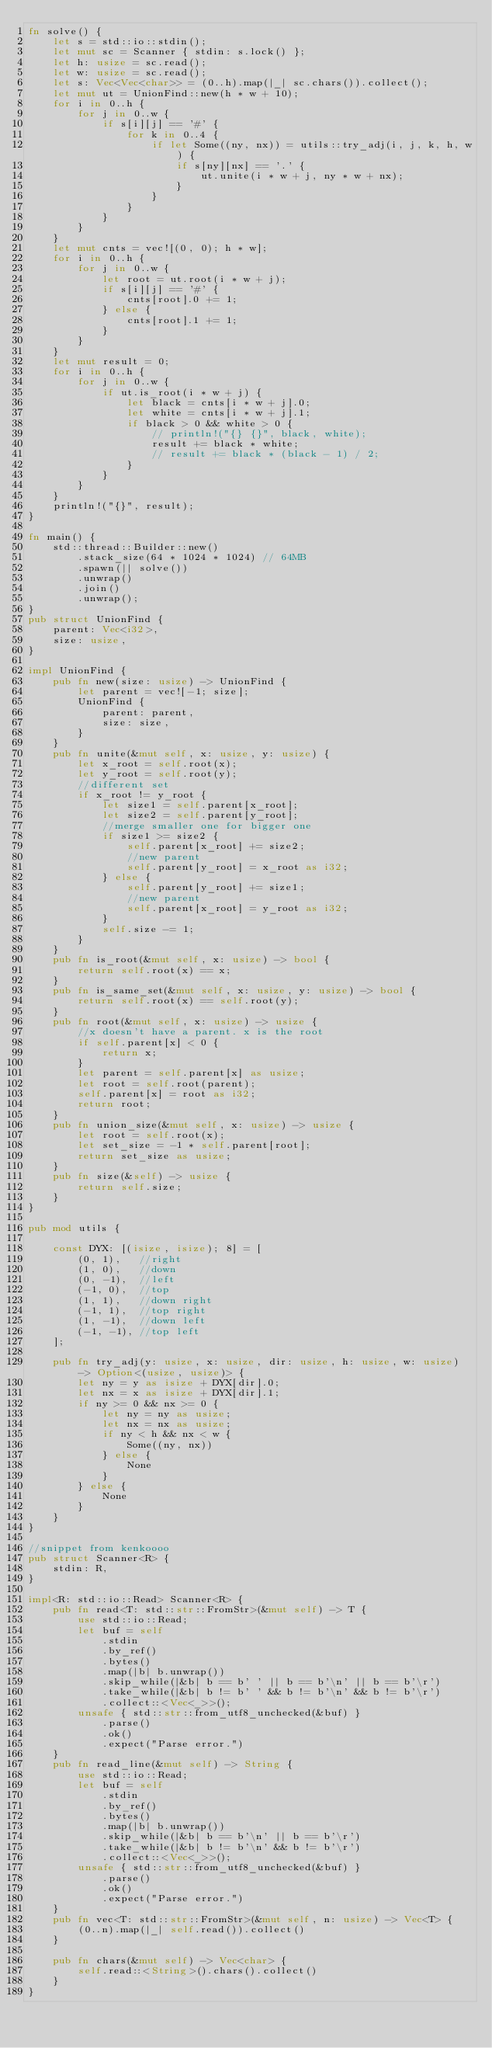Convert code to text. <code><loc_0><loc_0><loc_500><loc_500><_Rust_>fn solve() {
    let s = std::io::stdin();
    let mut sc = Scanner { stdin: s.lock() };
    let h: usize = sc.read();
    let w: usize = sc.read();
    let s: Vec<Vec<char>> = (0..h).map(|_| sc.chars()).collect();
    let mut ut = UnionFind::new(h * w + 10);
    for i in 0..h {
        for j in 0..w {
            if s[i][j] == '#' {
                for k in 0..4 {
                    if let Some((ny, nx)) = utils::try_adj(i, j, k, h, w) {
                        if s[ny][nx] == '.' {
                            ut.unite(i * w + j, ny * w + nx);
                        }
                    }
                }
            }
        }
    }
    let mut cnts = vec![(0, 0); h * w];
    for i in 0..h {
        for j in 0..w {
            let root = ut.root(i * w + j);
            if s[i][j] == '#' {
                cnts[root].0 += 1;
            } else {
                cnts[root].1 += 1;
            }
        }
    }
    let mut result = 0;
    for i in 0..h {
        for j in 0..w {
            if ut.is_root(i * w + j) {
                let black = cnts[i * w + j].0;
                let white = cnts[i * w + j].1;
                if black > 0 && white > 0 {
                    // println!("{} {}", black, white);
                    result += black * white;
                    // result += black * (black - 1) / 2;
                }
            }
        }
    }
    println!("{}", result);
}

fn main() {
    std::thread::Builder::new()
        .stack_size(64 * 1024 * 1024) // 64MB
        .spawn(|| solve())
        .unwrap()
        .join()
        .unwrap();
}
pub struct UnionFind {
    parent: Vec<i32>,
    size: usize,
}

impl UnionFind {
    pub fn new(size: usize) -> UnionFind {
        let parent = vec![-1; size];
        UnionFind {
            parent: parent,
            size: size,
        }
    }
    pub fn unite(&mut self, x: usize, y: usize) {
        let x_root = self.root(x);
        let y_root = self.root(y);
        //different set
        if x_root != y_root {
            let size1 = self.parent[x_root];
            let size2 = self.parent[y_root];
            //merge smaller one for bigger one
            if size1 >= size2 {
                self.parent[x_root] += size2;
                //new parent
                self.parent[y_root] = x_root as i32;
            } else {
                self.parent[y_root] += size1;
                //new parent
                self.parent[x_root] = y_root as i32;
            }
            self.size -= 1;
        }
    }
    pub fn is_root(&mut self, x: usize) -> bool {
        return self.root(x) == x;
    }
    pub fn is_same_set(&mut self, x: usize, y: usize) -> bool {
        return self.root(x) == self.root(y);
    }
    pub fn root(&mut self, x: usize) -> usize {
        //x doesn't have a parent. x is the root
        if self.parent[x] < 0 {
            return x;
        }
        let parent = self.parent[x] as usize;
        let root = self.root(parent);
        self.parent[x] = root as i32;
        return root;
    }
    pub fn union_size(&mut self, x: usize) -> usize {
        let root = self.root(x);
        let set_size = -1 * self.parent[root];
        return set_size as usize;
    }
    pub fn size(&self) -> usize {
        return self.size;
    }
}

pub mod utils {

    const DYX: [(isize, isize); 8] = [
        (0, 1),   //right
        (1, 0),   //down
        (0, -1),  //left
        (-1, 0),  //top
        (1, 1),   //down right
        (-1, 1),  //top right
        (1, -1),  //down left
        (-1, -1), //top left
    ];

    pub fn try_adj(y: usize, x: usize, dir: usize, h: usize, w: usize) -> Option<(usize, usize)> {
        let ny = y as isize + DYX[dir].0;
        let nx = x as isize + DYX[dir].1;
        if ny >= 0 && nx >= 0 {
            let ny = ny as usize;
            let nx = nx as usize;
            if ny < h && nx < w {
                Some((ny, nx))
            } else {
                None
            }
        } else {
            None
        }
    }
}

//snippet from kenkoooo
pub struct Scanner<R> {
    stdin: R,
}

impl<R: std::io::Read> Scanner<R> {
    pub fn read<T: std::str::FromStr>(&mut self) -> T {
        use std::io::Read;
        let buf = self
            .stdin
            .by_ref()
            .bytes()
            .map(|b| b.unwrap())
            .skip_while(|&b| b == b' ' || b == b'\n' || b == b'\r')
            .take_while(|&b| b != b' ' && b != b'\n' && b != b'\r')
            .collect::<Vec<_>>();
        unsafe { std::str::from_utf8_unchecked(&buf) }
            .parse()
            .ok()
            .expect("Parse error.")
    }
    pub fn read_line(&mut self) -> String {
        use std::io::Read;
        let buf = self
            .stdin
            .by_ref()
            .bytes()
            .map(|b| b.unwrap())
            .skip_while(|&b| b == b'\n' || b == b'\r')
            .take_while(|&b| b != b'\n' && b != b'\r')
            .collect::<Vec<_>>();
        unsafe { std::str::from_utf8_unchecked(&buf) }
            .parse()
            .ok()
            .expect("Parse error.")
    }
    pub fn vec<T: std::str::FromStr>(&mut self, n: usize) -> Vec<T> {
        (0..n).map(|_| self.read()).collect()
    }

    pub fn chars(&mut self) -> Vec<char> {
        self.read::<String>().chars().collect()
    }
}
</code> 